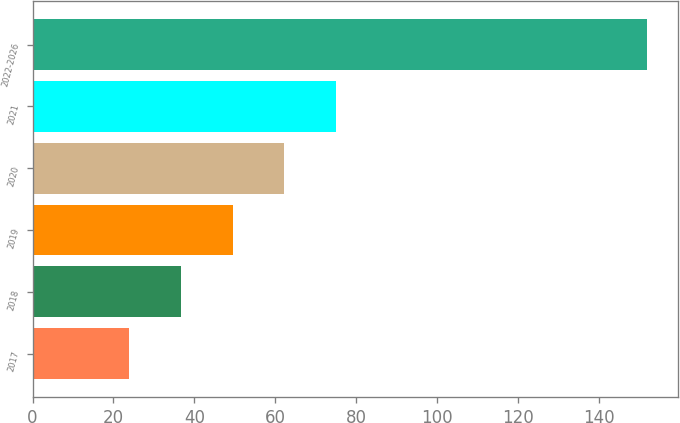Convert chart to OTSL. <chart><loc_0><loc_0><loc_500><loc_500><bar_chart><fcel>2017<fcel>2018<fcel>2019<fcel>2020<fcel>2021<fcel>2022-2026<nl><fcel>23.9<fcel>36.7<fcel>49.5<fcel>62.3<fcel>75.1<fcel>151.9<nl></chart> 